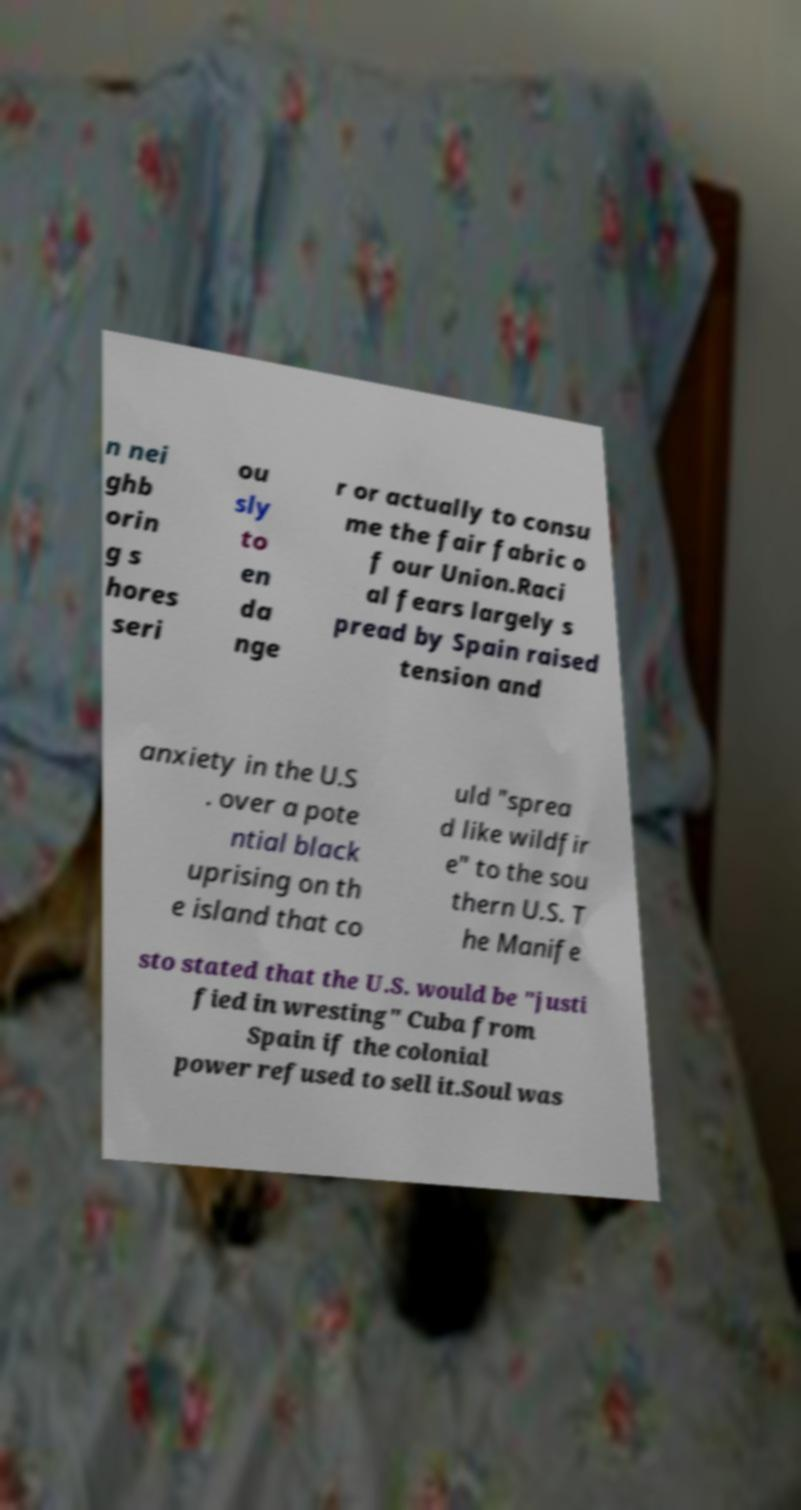There's text embedded in this image that I need extracted. Can you transcribe it verbatim? n nei ghb orin g s hores seri ou sly to en da nge r or actually to consu me the fair fabric o f our Union.Raci al fears largely s pread by Spain raised tension and anxiety in the U.S . over a pote ntial black uprising on th e island that co uld "sprea d like wildfir e" to the sou thern U.S. T he Manife sto stated that the U.S. would be "justi fied in wresting" Cuba from Spain if the colonial power refused to sell it.Soul was 